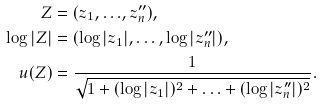<formula> <loc_0><loc_0><loc_500><loc_500>Z & = ( z _ { 1 } , { \dots } , z ^ { \prime \prime } _ { n } ) , \\ \log | Z | & = ( \log | z _ { 1 } | , \dots , \log | z ^ { \prime \prime } _ { n } | ) , \\ u ( Z ) & = \frac { 1 } { \sqrt { 1 + ( \log | z _ { 1 } | ) ^ { 2 } + { \dots } + ( \log | z ^ { \prime \prime } _ { n } | ) ^ { 2 } } } .</formula> 